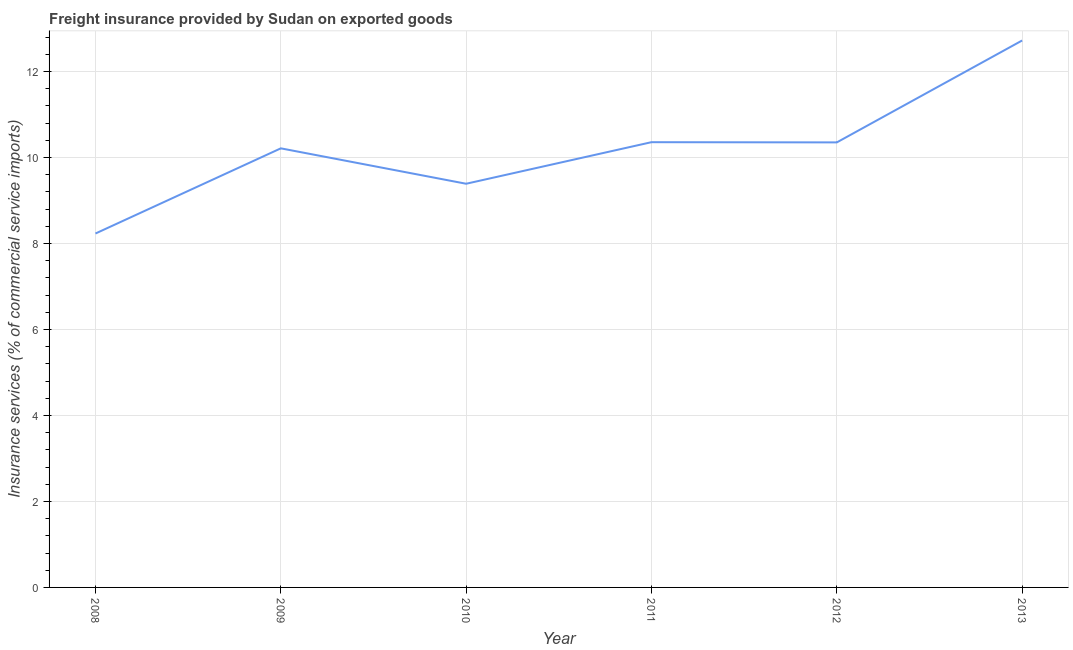What is the freight insurance in 2009?
Your answer should be compact. 10.21. Across all years, what is the maximum freight insurance?
Your response must be concise. 12.72. Across all years, what is the minimum freight insurance?
Your answer should be compact. 8.23. What is the sum of the freight insurance?
Offer a terse response. 61.26. What is the difference between the freight insurance in 2010 and 2012?
Provide a short and direct response. -0.96. What is the average freight insurance per year?
Keep it short and to the point. 10.21. What is the median freight insurance?
Provide a succinct answer. 10.28. Do a majority of the years between 2009 and 2012 (inclusive) have freight insurance greater than 4.8 %?
Keep it short and to the point. Yes. What is the ratio of the freight insurance in 2008 to that in 2010?
Offer a terse response. 0.88. Is the freight insurance in 2009 less than that in 2010?
Provide a succinct answer. No. What is the difference between the highest and the second highest freight insurance?
Provide a succinct answer. 2.37. Is the sum of the freight insurance in 2010 and 2012 greater than the maximum freight insurance across all years?
Your answer should be very brief. Yes. What is the difference between the highest and the lowest freight insurance?
Keep it short and to the point. 4.49. Does the freight insurance monotonically increase over the years?
Your answer should be compact. No. How many years are there in the graph?
Ensure brevity in your answer.  6. Are the values on the major ticks of Y-axis written in scientific E-notation?
Provide a succinct answer. No. Does the graph contain grids?
Offer a terse response. Yes. What is the title of the graph?
Your answer should be compact. Freight insurance provided by Sudan on exported goods . What is the label or title of the Y-axis?
Your answer should be compact. Insurance services (% of commercial service imports). What is the Insurance services (% of commercial service imports) in 2008?
Your answer should be compact. 8.23. What is the Insurance services (% of commercial service imports) in 2009?
Your response must be concise. 10.21. What is the Insurance services (% of commercial service imports) of 2010?
Offer a terse response. 9.39. What is the Insurance services (% of commercial service imports) of 2011?
Your response must be concise. 10.36. What is the Insurance services (% of commercial service imports) in 2012?
Provide a short and direct response. 10.35. What is the Insurance services (% of commercial service imports) of 2013?
Offer a very short reply. 12.72. What is the difference between the Insurance services (% of commercial service imports) in 2008 and 2009?
Offer a terse response. -1.98. What is the difference between the Insurance services (% of commercial service imports) in 2008 and 2010?
Ensure brevity in your answer.  -1.16. What is the difference between the Insurance services (% of commercial service imports) in 2008 and 2011?
Offer a very short reply. -2.12. What is the difference between the Insurance services (% of commercial service imports) in 2008 and 2012?
Ensure brevity in your answer.  -2.12. What is the difference between the Insurance services (% of commercial service imports) in 2008 and 2013?
Provide a succinct answer. -4.49. What is the difference between the Insurance services (% of commercial service imports) in 2009 and 2010?
Offer a terse response. 0.82. What is the difference between the Insurance services (% of commercial service imports) in 2009 and 2011?
Offer a very short reply. -0.14. What is the difference between the Insurance services (% of commercial service imports) in 2009 and 2012?
Keep it short and to the point. -0.14. What is the difference between the Insurance services (% of commercial service imports) in 2009 and 2013?
Offer a terse response. -2.51. What is the difference between the Insurance services (% of commercial service imports) in 2010 and 2011?
Provide a short and direct response. -0.97. What is the difference between the Insurance services (% of commercial service imports) in 2010 and 2012?
Provide a short and direct response. -0.96. What is the difference between the Insurance services (% of commercial service imports) in 2010 and 2013?
Make the answer very short. -3.33. What is the difference between the Insurance services (% of commercial service imports) in 2011 and 2012?
Give a very brief answer. 0. What is the difference between the Insurance services (% of commercial service imports) in 2011 and 2013?
Give a very brief answer. -2.37. What is the difference between the Insurance services (% of commercial service imports) in 2012 and 2013?
Your answer should be very brief. -2.37. What is the ratio of the Insurance services (% of commercial service imports) in 2008 to that in 2009?
Provide a succinct answer. 0.81. What is the ratio of the Insurance services (% of commercial service imports) in 2008 to that in 2010?
Give a very brief answer. 0.88. What is the ratio of the Insurance services (% of commercial service imports) in 2008 to that in 2011?
Your answer should be compact. 0.8. What is the ratio of the Insurance services (% of commercial service imports) in 2008 to that in 2012?
Keep it short and to the point. 0.8. What is the ratio of the Insurance services (% of commercial service imports) in 2008 to that in 2013?
Provide a succinct answer. 0.65. What is the ratio of the Insurance services (% of commercial service imports) in 2009 to that in 2010?
Offer a terse response. 1.09. What is the ratio of the Insurance services (% of commercial service imports) in 2009 to that in 2013?
Provide a succinct answer. 0.8. What is the ratio of the Insurance services (% of commercial service imports) in 2010 to that in 2011?
Provide a short and direct response. 0.91. What is the ratio of the Insurance services (% of commercial service imports) in 2010 to that in 2012?
Keep it short and to the point. 0.91. What is the ratio of the Insurance services (% of commercial service imports) in 2010 to that in 2013?
Provide a succinct answer. 0.74. What is the ratio of the Insurance services (% of commercial service imports) in 2011 to that in 2013?
Your answer should be very brief. 0.81. What is the ratio of the Insurance services (% of commercial service imports) in 2012 to that in 2013?
Your answer should be very brief. 0.81. 